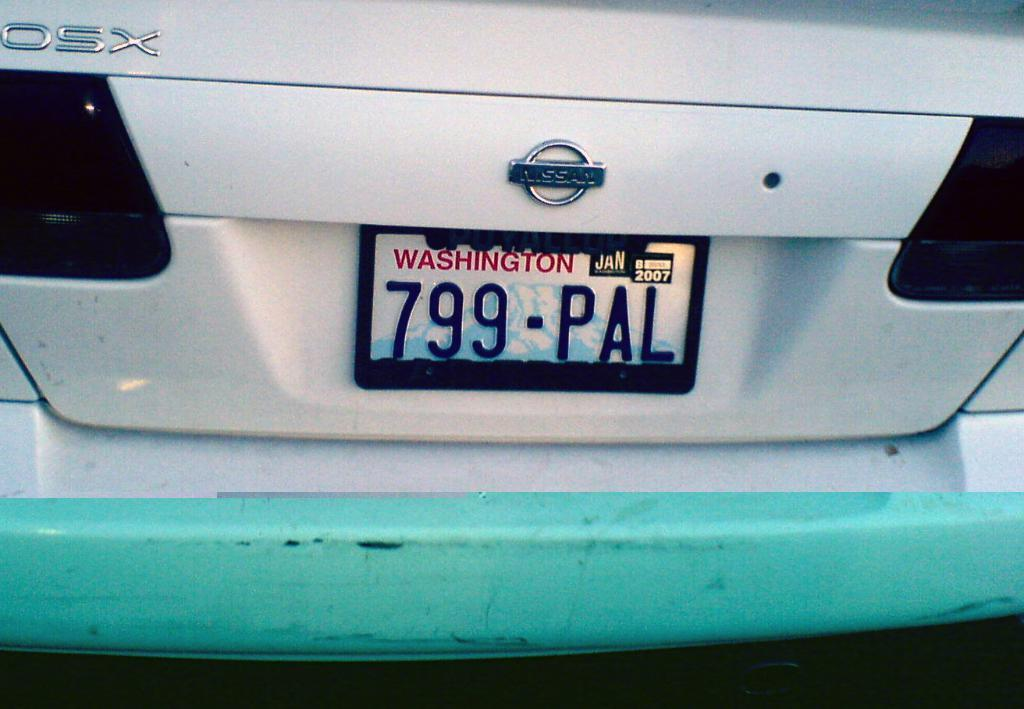Provide a one-sentence caption for the provided image. The back of a Nissan car showing its plates. 